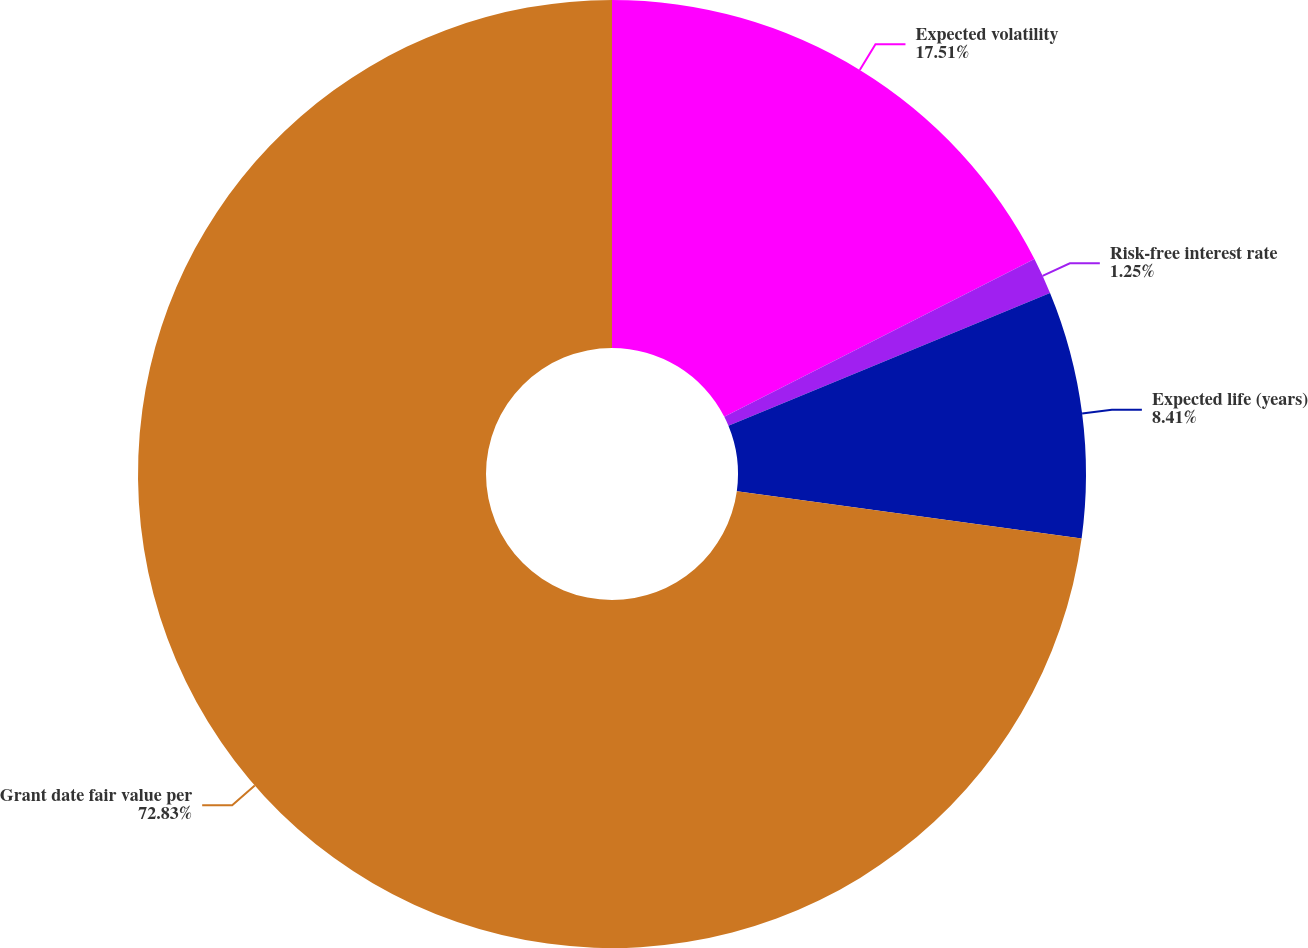Convert chart. <chart><loc_0><loc_0><loc_500><loc_500><pie_chart><fcel>Expected volatility<fcel>Risk-free interest rate<fcel>Expected life (years)<fcel>Grant date fair value per<nl><fcel>17.51%<fcel>1.25%<fcel>8.41%<fcel>72.83%<nl></chart> 